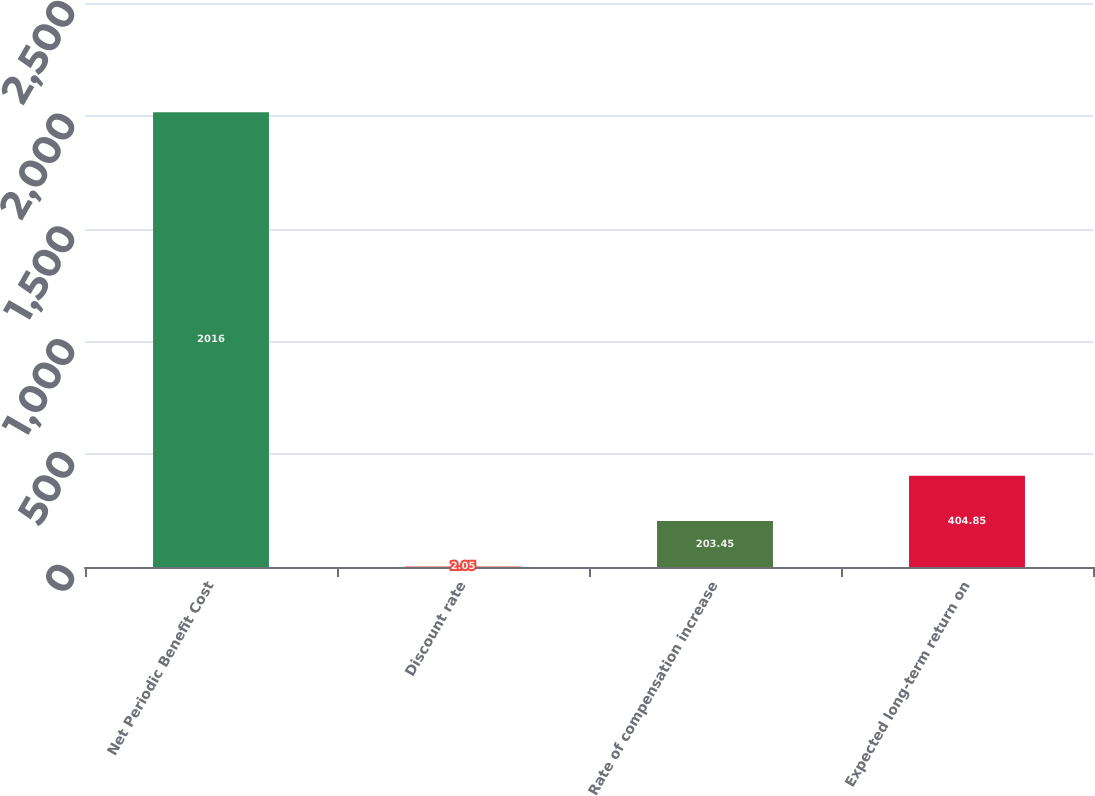<chart> <loc_0><loc_0><loc_500><loc_500><bar_chart><fcel>Net Periodic Benefit Cost<fcel>Discount rate<fcel>Rate of compensation increase<fcel>Expected long-term return on<nl><fcel>2016<fcel>2.05<fcel>203.45<fcel>404.85<nl></chart> 